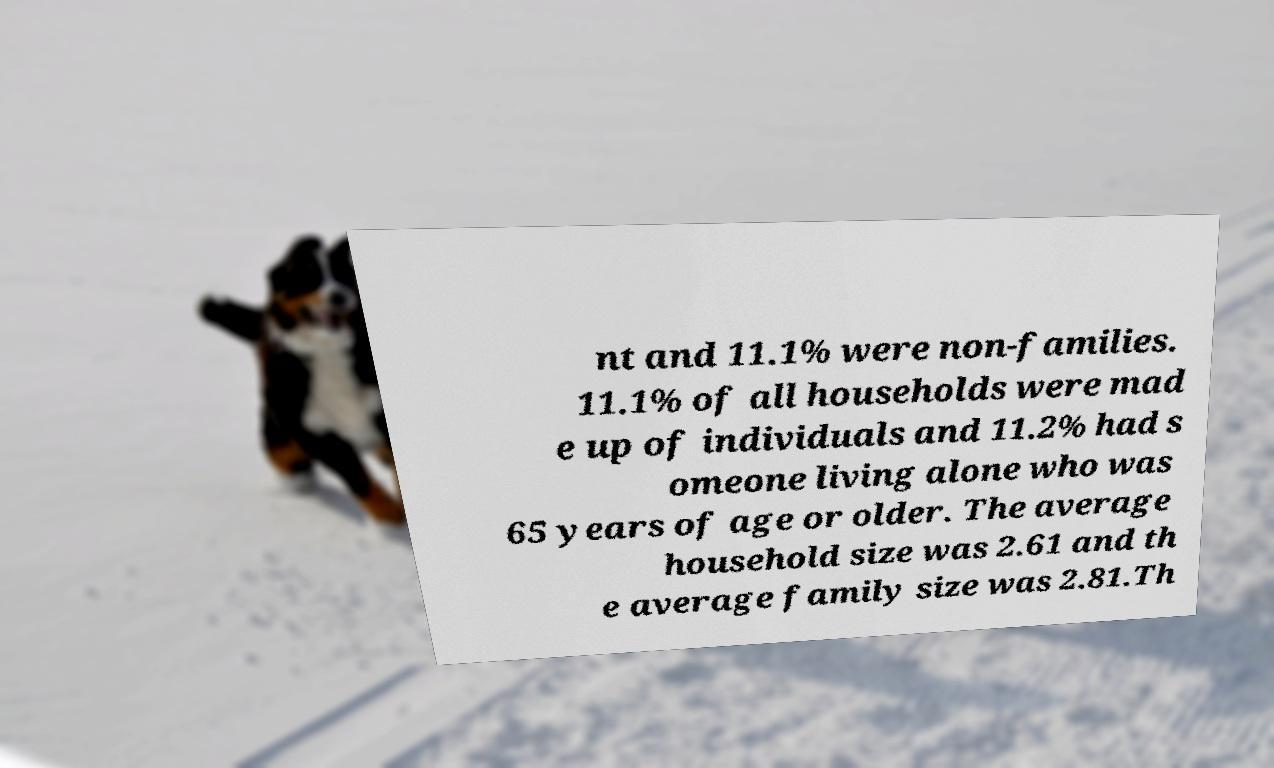I need the written content from this picture converted into text. Can you do that? nt and 11.1% were non-families. 11.1% of all households were mad e up of individuals and 11.2% had s omeone living alone who was 65 years of age or older. The average household size was 2.61 and th e average family size was 2.81.Th 